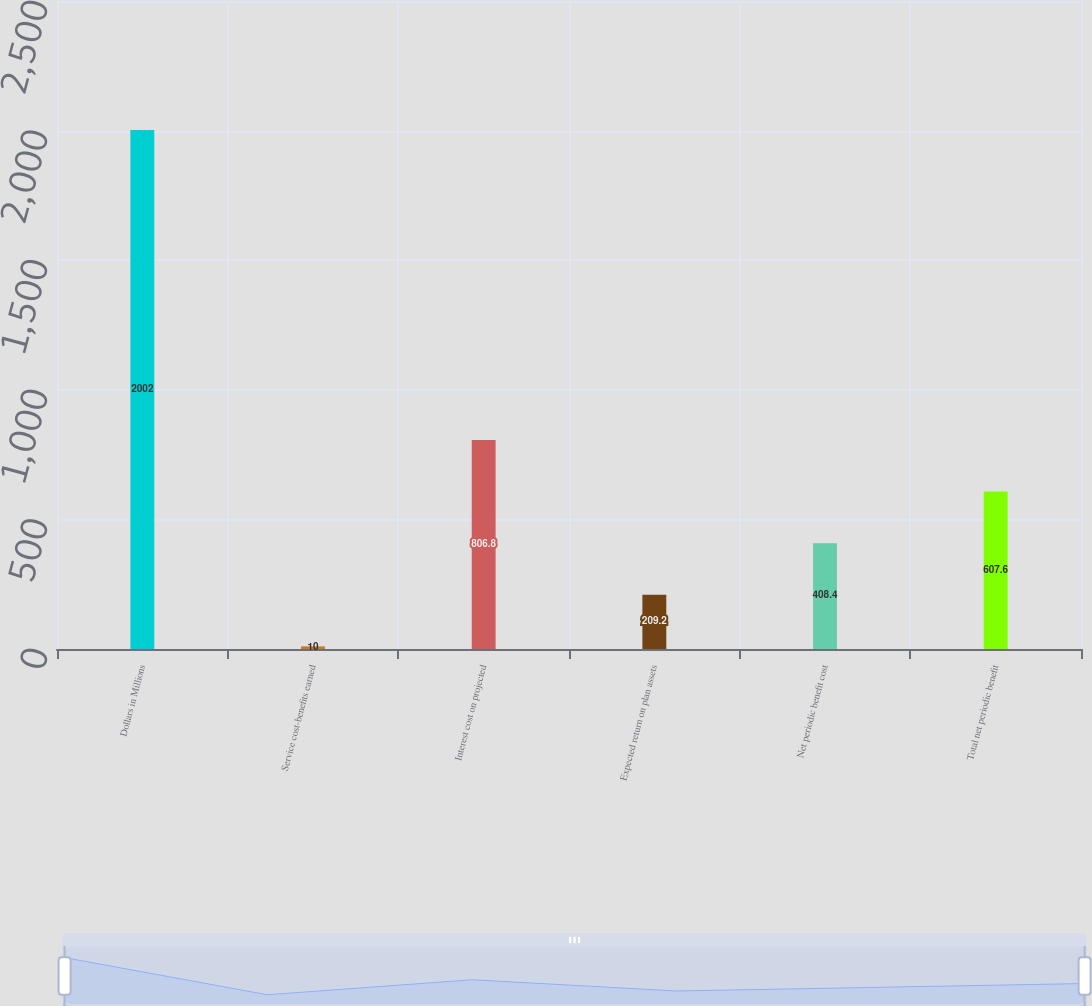Convert chart to OTSL. <chart><loc_0><loc_0><loc_500><loc_500><bar_chart><fcel>Dollars in Millions<fcel>Service cost-benefits earned<fcel>Interest cost on projected<fcel>Expected return on plan assets<fcel>Net periodic benefit cost<fcel>Total net periodic benefit<nl><fcel>2002<fcel>10<fcel>806.8<fcel>209.2<fcel>408.4<fcel>607.6<nl></chart> 